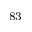<formula> <loc_0><loc_0><loc_500><loc_500>^ { 8 3 }</formula> 